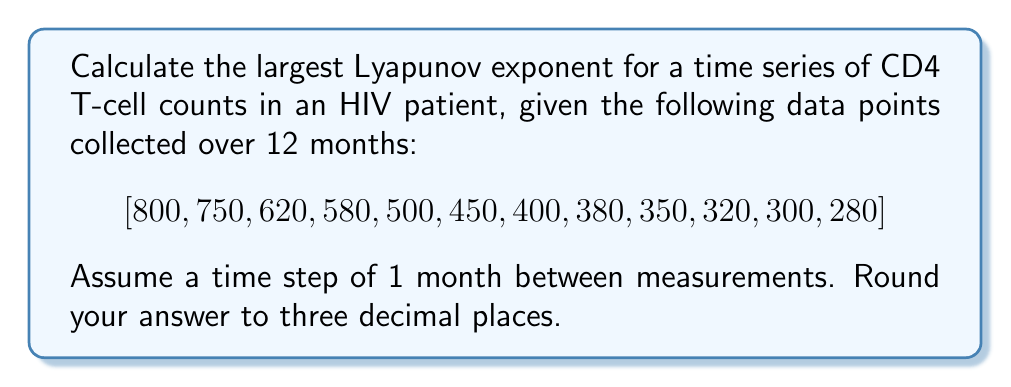Can you answer this question? To calculate the largest Lyapunov exponent for this time series, we'll follow these steps:

1) First, we need to calculate the rate of divergence between neighboring trajectories. For simplicity, we'll use the method of comparing successive points.

2) For each pair of successive points, calculate the difference:
   $$d_i = |x_{i+1} - x_i|$$

3) Calculate the natural logarithm of each difference:
   $$\ln(d_i)$$

4) The Lyapunov exponent λ is approximated by the average of these logarithms:
   $$\lambda \approx \frac{1}{N-1} \sum_{i=1}^{N-1} \ln(d_i)$$
   where N is the number of data points.

5) Let's calculate:
   $d_1 = |750 - 800| = 50$, $\ln(50) \approx 3.912$
   $d_2 = |620 - 750| = 130$, $\ln(130) \approx 4.868$
   $d_3 = |580 - 620| = 40$, $\ln(40) \approx 3.689$
   $d_4 = |500 - 580| = 80$, $\ln(80) \approx 4.382$
   $d_5 = |450 - 500| = 50$, $\ln(50) \approx 3.912$
   $d_6 = |400 - 450| = 50$, $\ln(50) \approx 3.912$
   $d_7 = |380 - 400| = 20$, $\ln(20) \approx 2.996$
   $d_8 = |350 - 380| = 30$, $\ln(30) \approx 3.401$
   $d_9 = |320 - 350| = 30$, $\ln(30) \approx 3.401$
   $d_{10} = |300 - 320| = 20$, $\ln(20) \approx 2.996$
   $d_{11} = |280 - 300| = 20$, $\ln(20) \approx 2.996$

6) Sum these logarithms:
   $\sum_{i=1}^{11} \ln(d_i) \approx 40.465$

7) Divide by (N-1) = 11:
   $$\lambda \approx \frac{40.465}{11} \approx 3.679$$

8) Round to three decimal places: 3.679

The positive Lyapunov exponent indicates chaotic behavior in the CD4 T-cell count, suggesting unpredictable fluctuations in the patient's immune response to HIV.
Answer: 3.679 